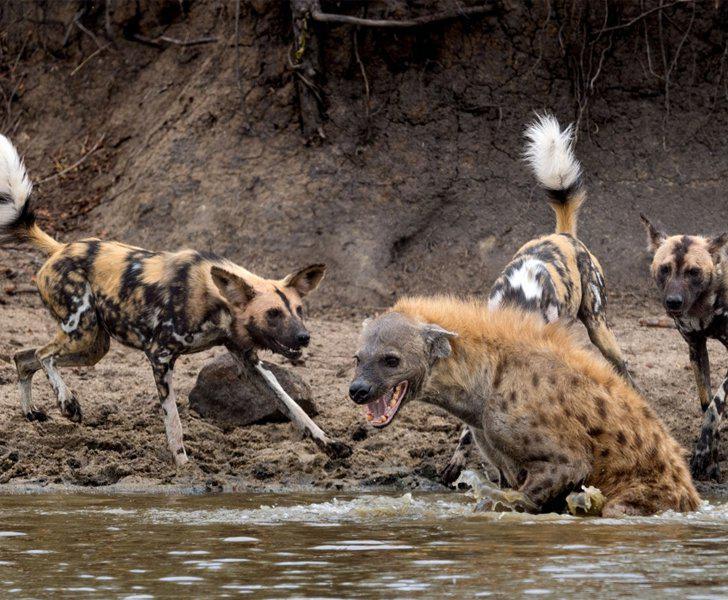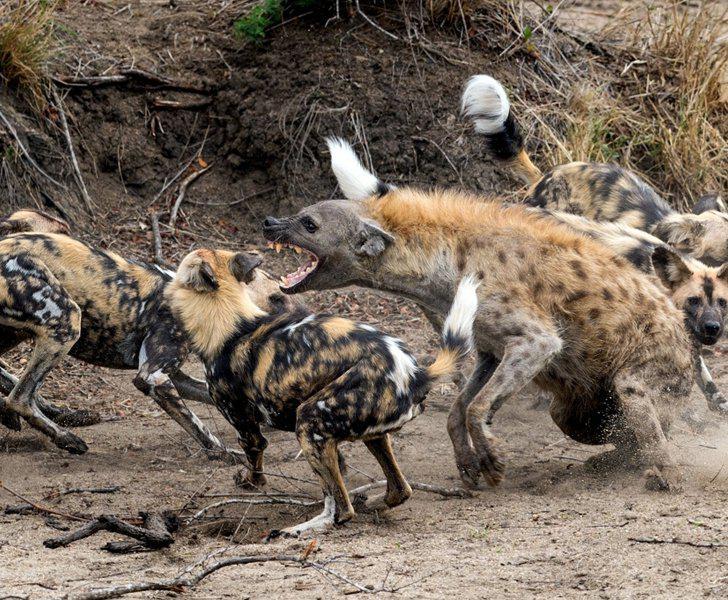The first image is the image on the left, the second image is the image on the right. Evaluate the accuracy of this statement regarding the images: "An image shows different scavenger animals, including hyena, around a carcass.". Is it true? Answer yes or no. No. The first image is the image on the left, the second image is the image on the right. Assess this claim about the two images: "Hyenas are by a body of water.". Correct or not? Answer yes or no. Yes. 